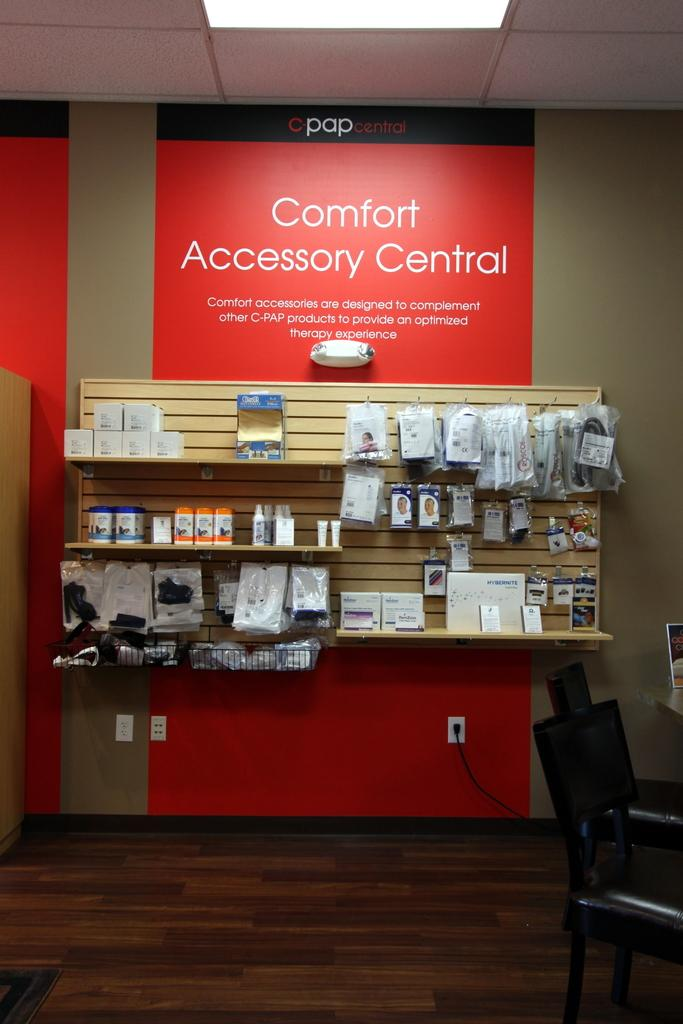Provide a one-sentence caption for the provided image. A display offers a variety of comfort accessories presented on shelves. 